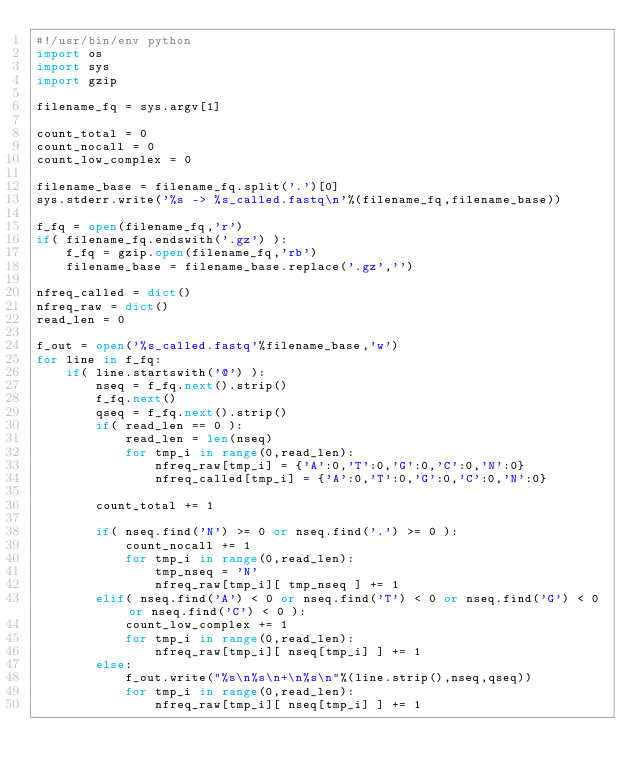Convert code to text. <code><loc_0><loc_0><loc_500><loc_500><_Python_>#!/usr/bin/env python
import os
import sys
import gzip

filename_fq = sys.argv[1]

count_total = 0
count_nocall = 0
count_low_complex = 0

filename_base = filename_fq.split('.')[0]
sys.stderr.write('%s -> %s_called.fastq\n'%(filename_fq,filename_base))

f_fq = open(filename_fq,'r')
if( filename_fq.endswith('.gz') ):
    f_fq = gzip.open(filename_fq,'rb')
    filename_base = filename_base.replace('.gz','')

nfreq_called = dict()
nfreq_raw = dict()
read_len = 0

f_out = open('%s_called.fastq'%filename_base,'w')
for line in f_fq:
    if( line.startswith('@') ):
        nseq = f_fq.next().strip()
        f_fq.next()
        qseq = f_fq.next().strip()
        if( read_len == 0 ):
            read_len = len(nseq)
            for tmp_i in range(0,read_len):
                nfreq_raw[tmp_i] = {'A':0,'T':0,'G':0,'C':0,'N':0}
                nfreq_called[tmp_i] = {'A':0,'T':0,'G':0,'C':0,'N':0}
        
        count_total += 1

        if( nseq.find('N') >= 0 or nseq.find('.') >= 0 ):
            count_nocall += 1
            for tmp_i in range(0,read_len):
                tmp_nseq = 'N'
                nfreq_raw[tmp_i][ tmp_nseq ] += 1
        elif( nseq.find('A') < 0 or nseq.find('T') < 0 or nseq.find('G') < 0 or nseq.find('C') < 0 ):
            count_low_complex += 1
            for tmp_i in range(0,read_len):
                nfreq_raw[tmp_i][ nseq[tmp_i] ] += 1
        else:
            f_out.write("%s\n%s\n+\n%s\n"%(line.strip(),nseq,qseq))
            for tmp_i in range(0,read_len):
                nfreq_raw[tmp_i][ nseq[tmp_i] ] += 1</code> 